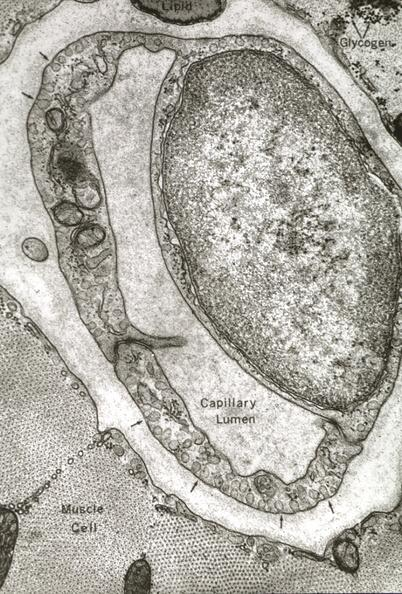s cardiovascular present?
Answer the question using a single word or phrase. Yes 